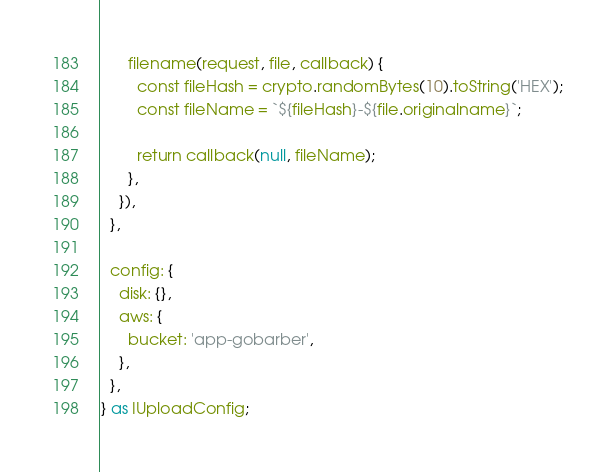<code> <loc_0><loc_0><loc_500><loc_500><_TypeScript_>
      filename(request, file, callback) {
        const fileHash = crypto.randomBytes(10).toString('HEX');
        const fileName = `${fileHash}-${file.originalname}`;

        return callback(null, fileName);
      },
    }),
  },

  config: {
    disk: {},
    aws: {
      bucket: 'app-gobarber',
    },
  },
} as IUploadConfig;
</code> 